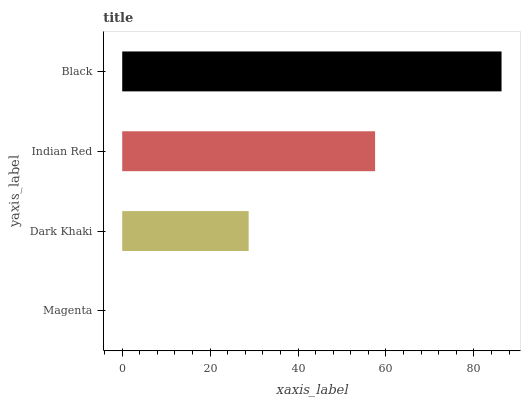Is Magenta the minimum?
Answer yes or no. Yes. Is Black the maximum?
Answer yes or no. Yes. Is Dark Khaki the minimum?
Answer yes or no. No. Is Dark Khaki the maximum?
Answer yes or no. No. Is Dark Khaki greater than Magenta?
Answer yes or no. Yes. Is Magenta less than Dark Khaki?
Answer yes or no. Yes. Is Magenta greater than Dark Khaki?
Answer yes or no. No. Is Dark Khaki less than Magenta?
Answer yes or no. No. Is Indian Red the high median?
Answer yes or no. Yes. Is Dark Khaki the low median?
Answer yes or no. Yes. Is Black the high median?
Answer yes or no. No. Is Indian Red the low median?
Answer yes or no. No. 